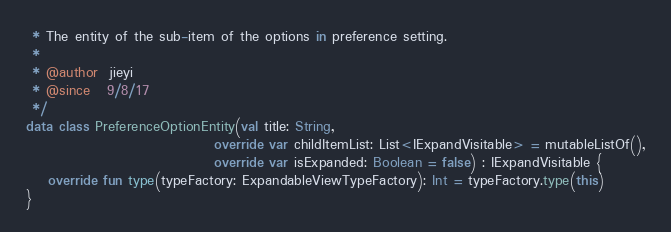<code> <loc_0><loc_0><loc_500><loc_500><_Kotlin_> * The entity of the sub-item of the options in preference setting.
 *
 * @author  jieyi
 * @since   9/8/17
 */
data class PreferenceOptionEntity(val title: String,
                                  override var childItemList: List<IExpandVisitable> = mutableListOf(),
                                  override var isExpanded: Boolean = false) : IExpandVisitable {
    override fun type(typeFactory: ExpandableViewTypeFactory): Int = typeFactory.type(this)
}</code> 